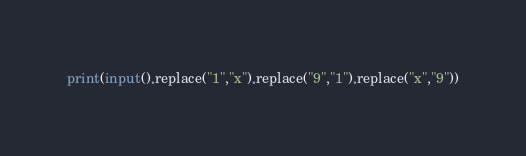Convert code to text. <code><loc_0><loc_0><loc_500><loc_500><_Python_>print(input().replace("1","x").replace("9","1").replace("x","9"))</code> 